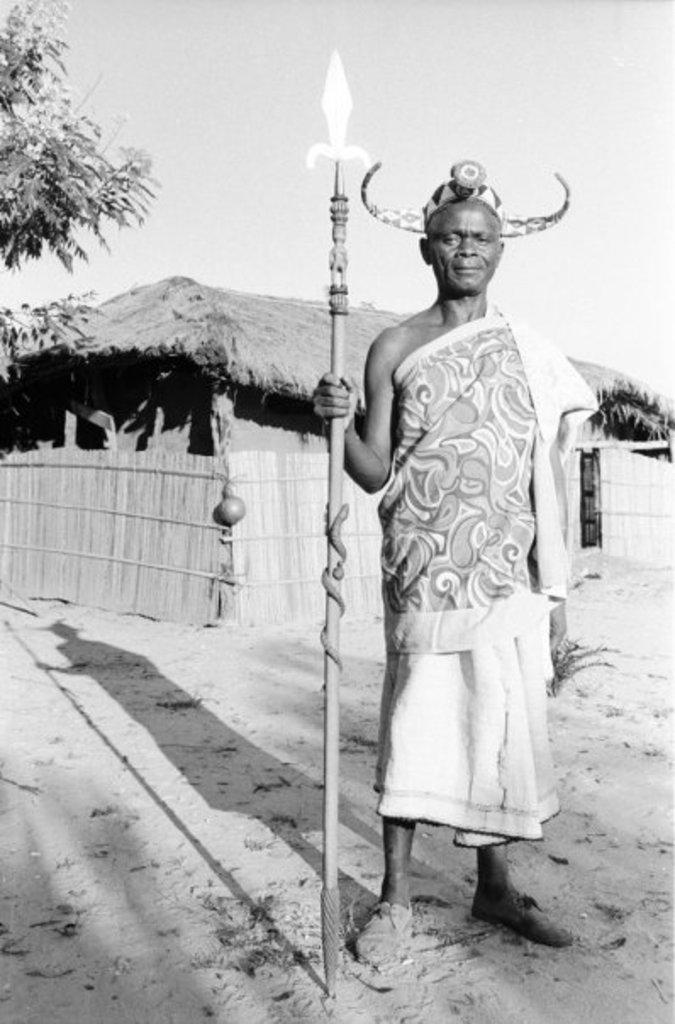What is the color scheme of the image? The image is black and white. Who is present in the image? There is a man in the image. What is the man doing in the image? The man is standing in front of a hut. What is the man holding in his hand? The man is holding a stick in his hand. What is the man wearing on his head? The man is wearing a crown. What can be seen on the left side of the image? There is a tree on the left side of the image. How many bears are sitting in the nest in the image? There are no bears or nests present in the image. 